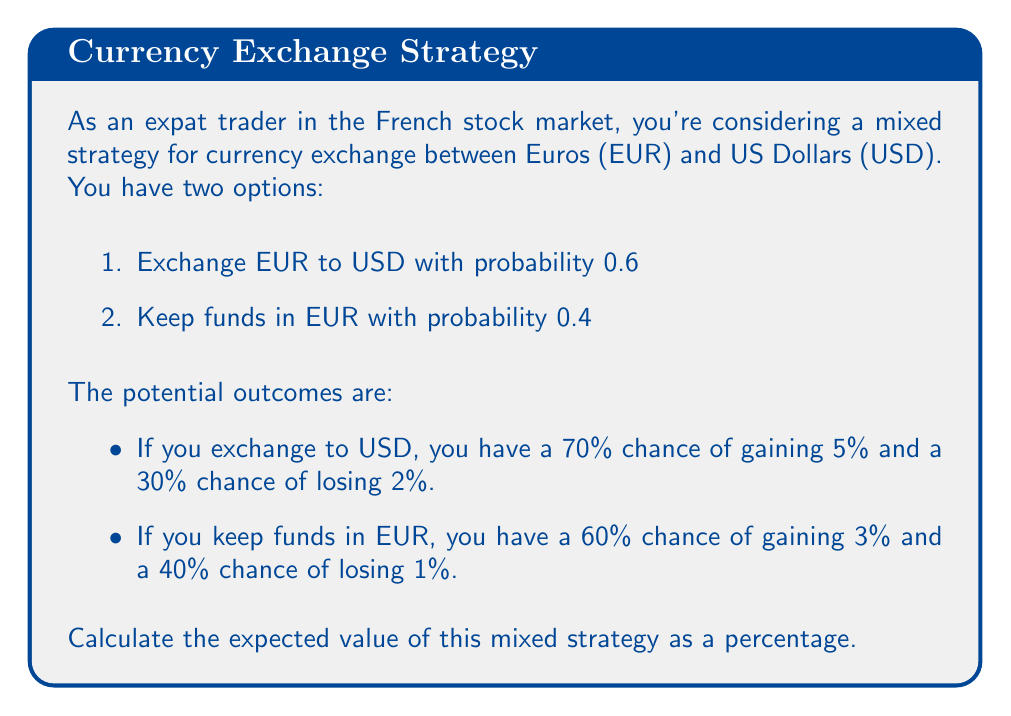Can you answer this question? To solve this problem, we need to calculate the expected value of each option and then combine them according to the probabilities of the mixed strategy.

1. Expected value of exchanging EUR to USD:
   $$EV_{USD} = 0.70 \times 5\% + 0.30 \times (-2\%) = 3.5\% - 0.6\% = 2.9\%$$

2. Expected value of keeping funds in EUR:
   $$EV_{EUR} = 0.60 \times 3\% + 0.40 \times (-1\%) = 1.8\% - 0.4\% = 1.4\%$$

3. Expected value of the mixed strategy:
   $$EV_{mixed} = 0.6 \times EV_{USD} + 0.4 \times EV_{EUR}$$
   $$EV_{mixed} = 0.6 \times 2.9\% + 0.4 \times 1.4\%$$
   $$EV_{mixed} = 1.74\% + 0.56\% = 2.3\%$$

Therefore, the expected value of the mixed strategy is 2.3%.
Answer: 2.3% 